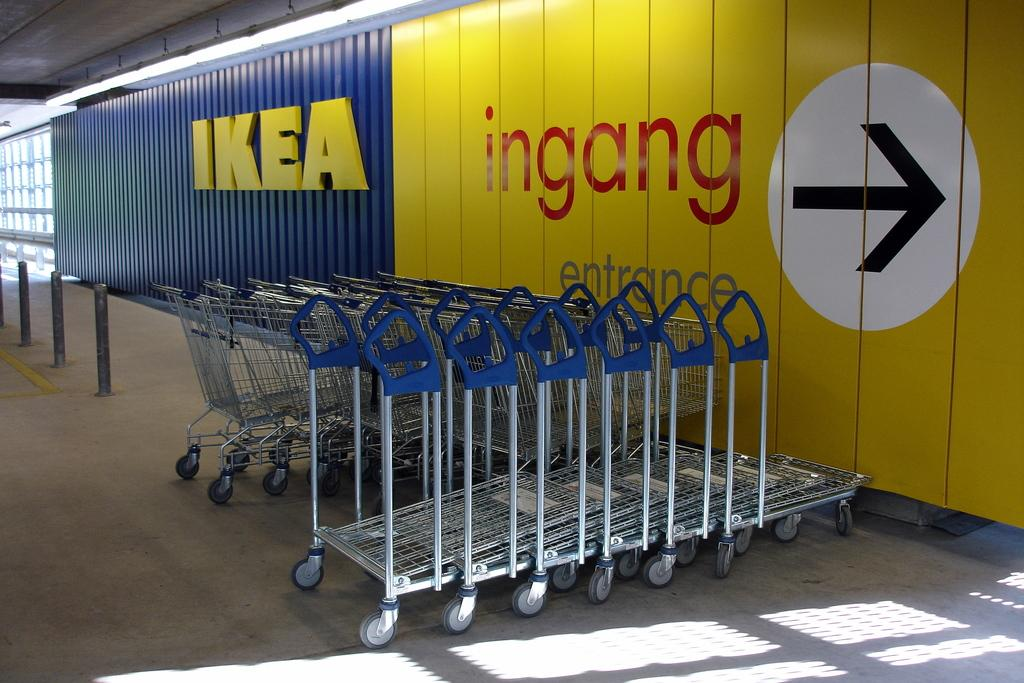What objects are present in the image? There are carts and metal rods in the image. What is written or displayed on the carts? There is text on the wall inside the carts. What can be seen at the top of the image? Lights are visible at the top of the image. How many servants are standing next to the carts in the image? There are no servants present in the image. Who is the friend that is mentioned in the text on the carts? There is no mention of a friend in the text on the carts. 